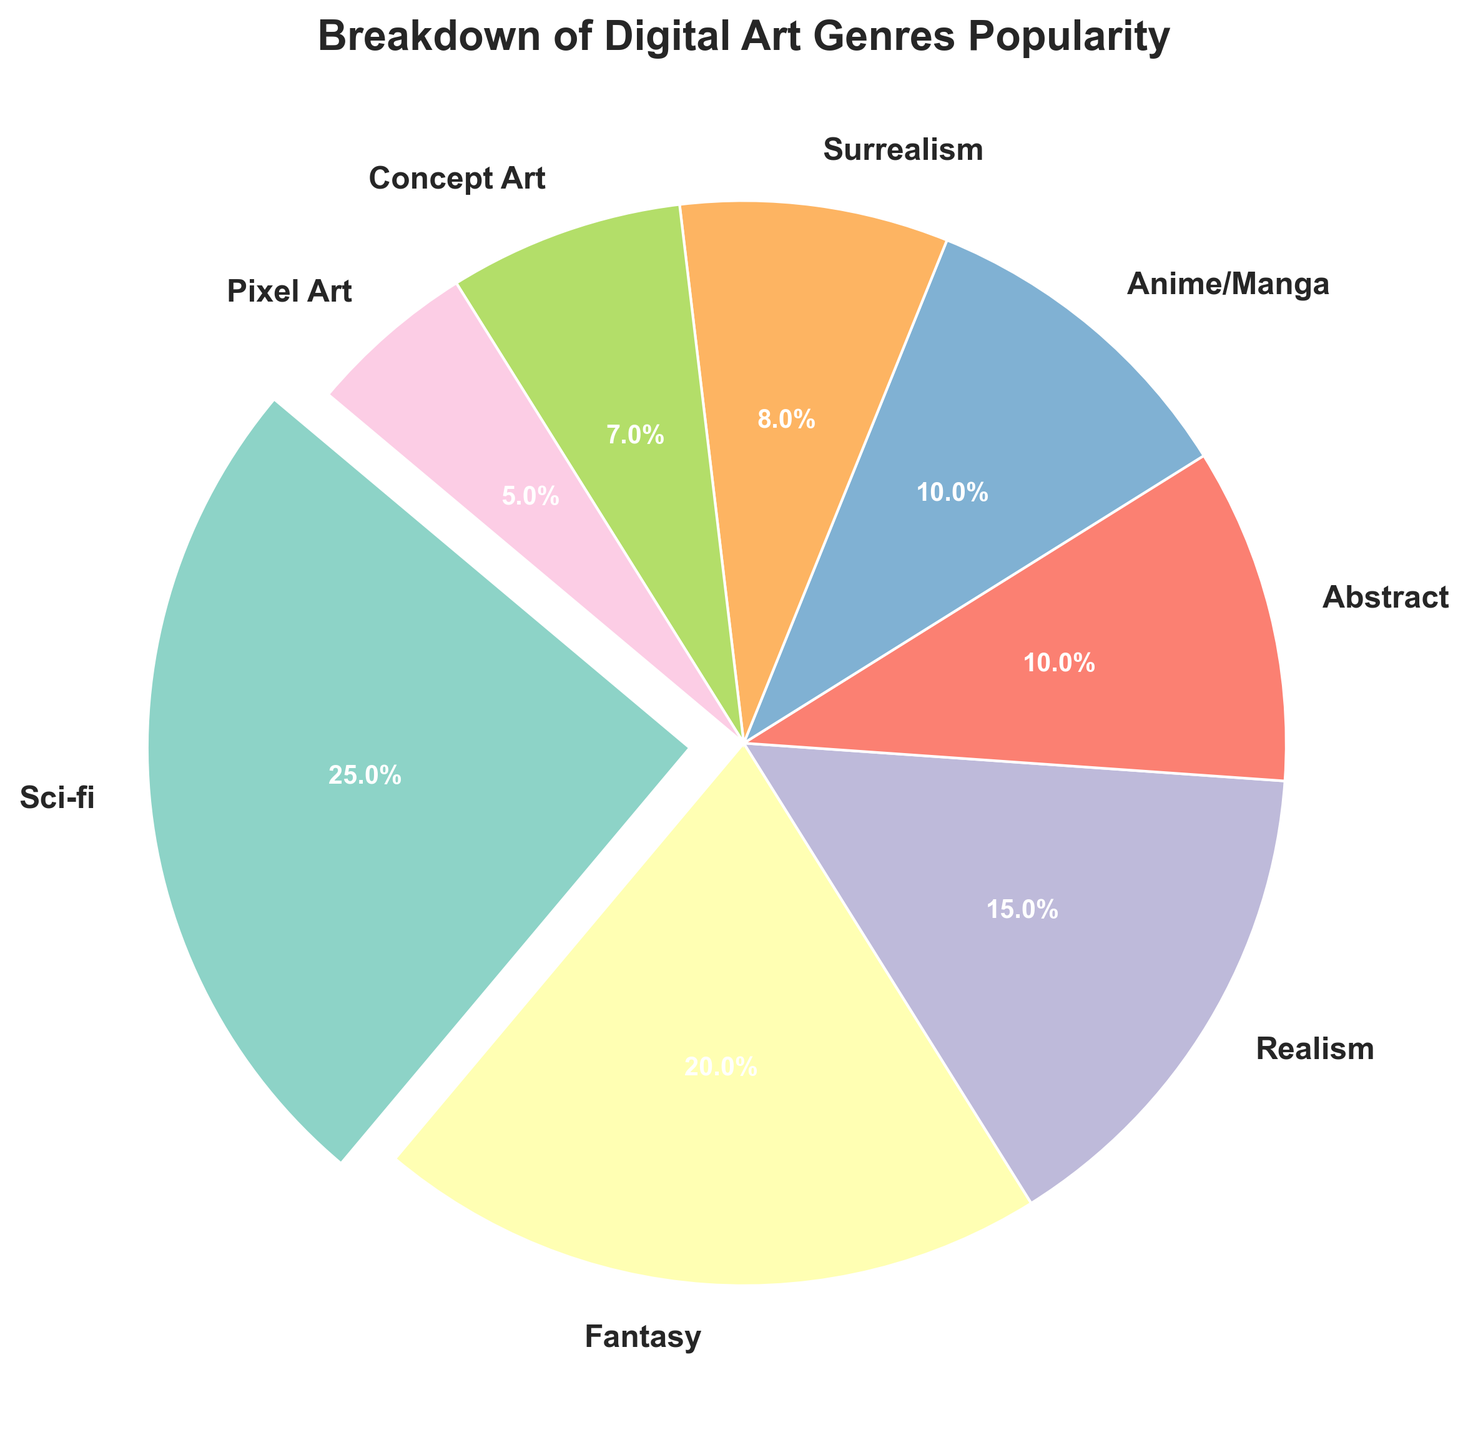Which genre is the most popular? The sci-fi genre has the largest portion of the pie chart, which indicates it has the highest popularity percentage.
Answer: Sci-fi How much more popular is sci-fi compared to pixel art? Sci-fi has 25% popularity and pixel art has 5%. The difference in popularity is 25% - 5% = 20%.
Answer: 20% What's the combined percentage of the three least popular genres? The three least popular genres are Surrealism (8%), Concept Art (7%), and Pixel Art (5%). Summing them gives 8% + 7% + 5% = 20%.
Answer: 20% If you combine Fantasy and Abstract genres, do they together account for more popularity than Sci-fi? Fantasy has 20% and Abstract has 10%. Combined, they have 20% + 10% = 30%, which is more than Sci-fi's 25%.
Answer: Yes What's the percentage difference between Realism and Anime/Manga? Realism has 15% popularity and Anime/Manga has 10%. The difference is 15% - 10% = 5%.
Answer: 5% Which genre appears in purple color? The genre marked in purple is Surrealism.
Answer: Surrealism Is Concept Art more or less popular than Realism? Concept Art has 7% popularity whereas Realism has 15%, so Concept Art is less popular than Realism.
Answer: Less What is the total popularity percentage of genres having less than 10% individually? The genres with less than 10% are Surrealism (8%), Concept Art (7%), and Pixel Art (5%). Summing them gives 8% + 7% + 5% = 20%.
Answer: 20% Which genre has an orange-colored segment? The genre marked in orange color is Anime/Manga.
Answer: Anime/Manga If the percentages of Abstract and Sci-fi are switched, which genre becomes the least popular? If Sci-fi switches its 25% with Abstract's 10%, then Sci-fi will have 10% and Abstract will have 25%. The genre with the least percentage would then be Pixel Art at 5%.
Answer: Pixel Art 